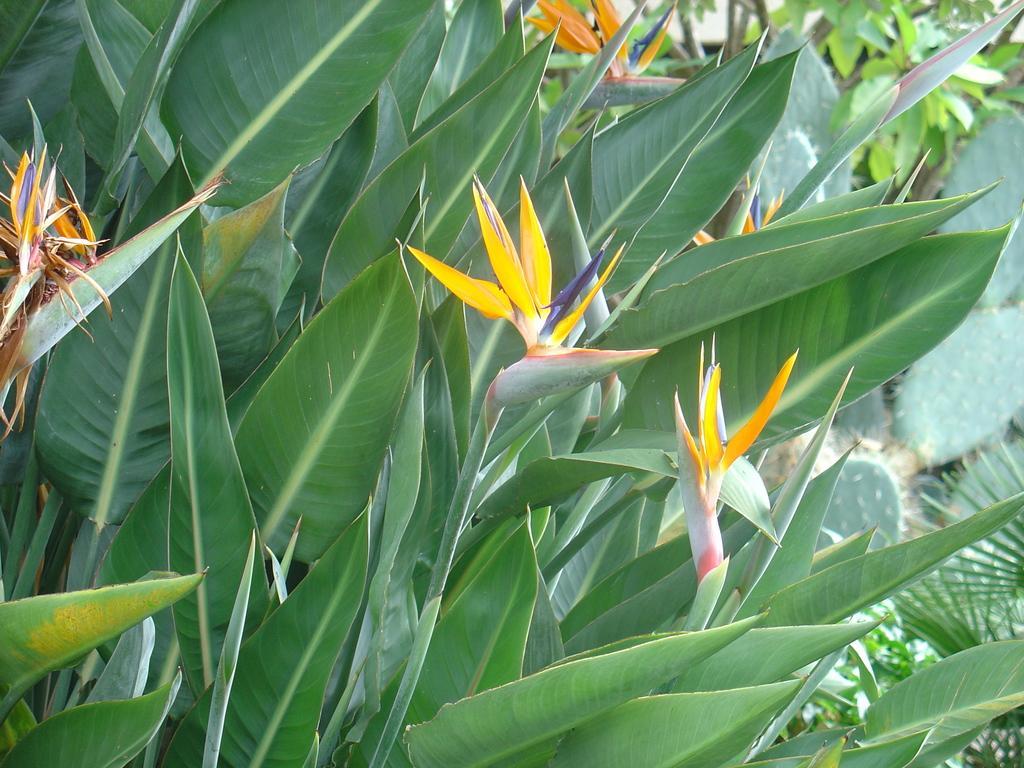How would you summarize this image in a sentence or two? There is a flower and some plants here. In the background we can observe a different plant. 